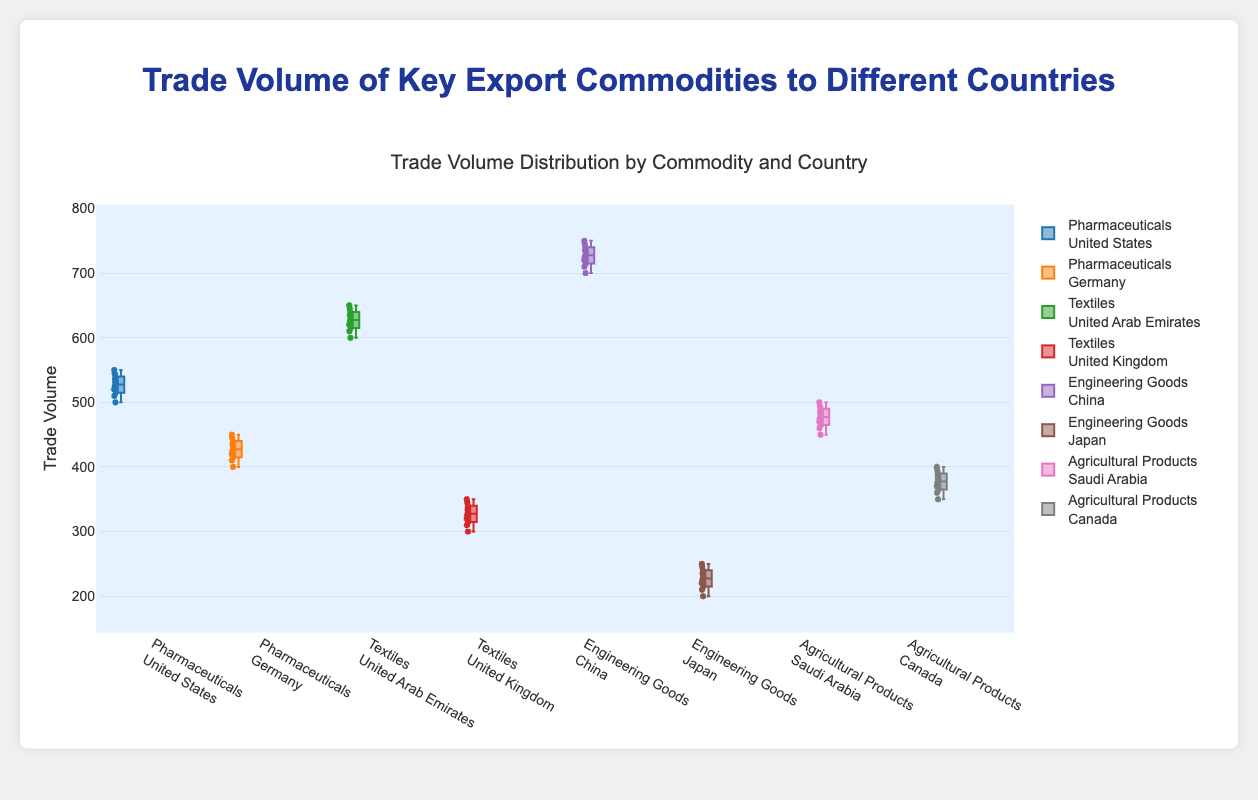What's the highest trade volume for Pharmaceuticals exported to the United States? To identify the highest trade volume of Pharmaceuticals exported to the United States, look at the maximum value on the y-axis for the corresponding box plot section labeled "Pharmaceuticals<br>United States".
Answer: 550 What is the median trade volume for Textiles exported to the United Kingdom? Locate the box plot for "Textiles<br>United Kingdom," then identify the line inside the box which represents the median value.
Answer: 325 Which commodity and country combination has the widest range of trade volumes? To determine the widest range, compare the highest and lowest values (whiskers) for all box plots. The difference between these values will give the range. The one with the largest value is the widest range.
Answer: Engineering Goods exported to China Is the median trade volume higher for Pharmaceuticals exported to the United States or to Germany? Look at the medians (lines inside the boxes) for the box plots labeled "Pharmaceuticals<br>United States" and "Pharmaceuticals<br>Germany" and compare their positions along the y-axis.
Answer: Pharmaceuticals exported to the United States What is the interquartile range (IQR) for Agricultural Products exported to Saudi Arabia? The IQR is the difference between the third quartile (top of the box) and first quartile (bottom of the box). Find these values in the box plot labeled "Agricultural Products<br>Saudi Arabia".
Answer: 30 How do the trade volumes of Engineering Goods exported to Japan compare with those exported to China? Compare the data points and range (whiskers) of the box plots for "Engineering Goods<br>Japan" and "Engineering Goods<br>China". The range and box size will indicate the variability and comparison.
Answer: Japan's trade volumes are lower and more varied than China's Which commodity and country combination has the lowest median trade volume? Look for the box plot with the lowest line inside the box (median value) across all commodities and countries.
Answer: Engineering Goods exported to Japan Between Textiles exported to the United Arab Emirates and the United Kingdom, which has a higher average trade volume? Although box plots do not directly show the average, the median serves as a robust approximation. Compare the medians of the box plots labeled "Textiles<br>United Arab Emirates" and "Textiles<br>United Kingdom".
Answer: United Arab Emirates What is the upper quartile for Pharmaceuticals exported to Germany? Find the box plot labeled "Pharmaceuticals<br>Germany," then identify the top of the box, which represents the upper (third) quartile.
Answer: 440 Are the trade volumes of Agricultural Products more consistent when exported to Saudi Arabia or Canada? Compare the lengths of the boxes and whiskers for "Agricultural Products<br>Saudi Arabia" and "Agricultural Products<br>Canada". Shorter ranges and boxes indicate more consistency.
Answer: Saudi Arabia 